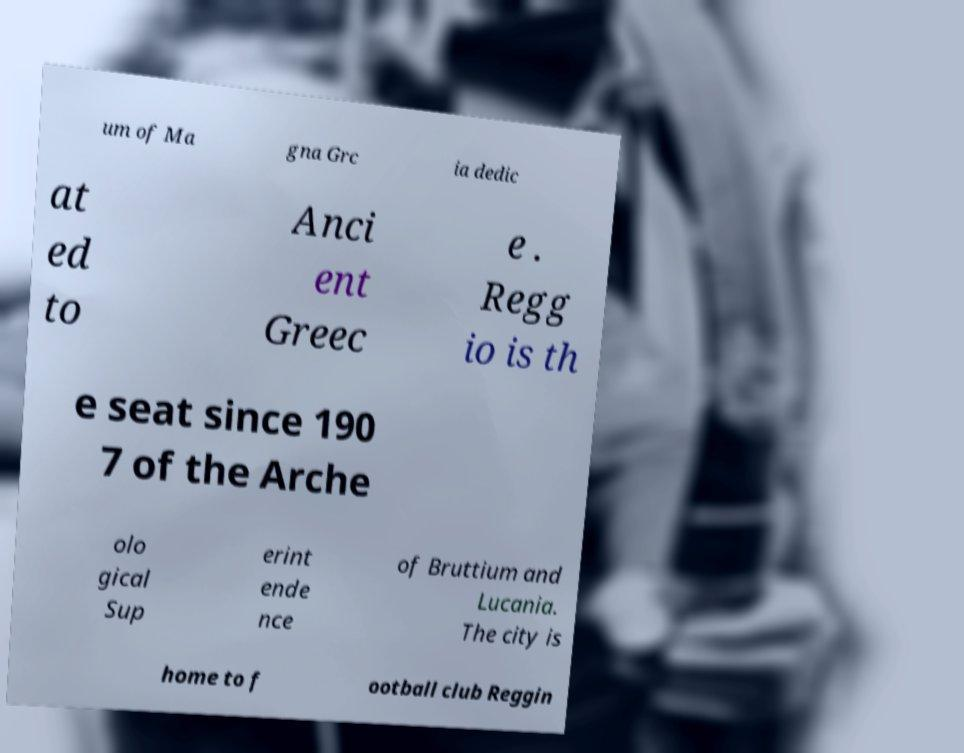What messages or text are displayed in this image? I need them in a readable, typed format. um of Ma gna Grc ia dedic at ed to Anci ent Greec e . Regg io is th e seat since 190 7 of the Arche olo gical Sup erint ende nce of Bruttium and Lucania. The city is home to f ootball club Reggin 